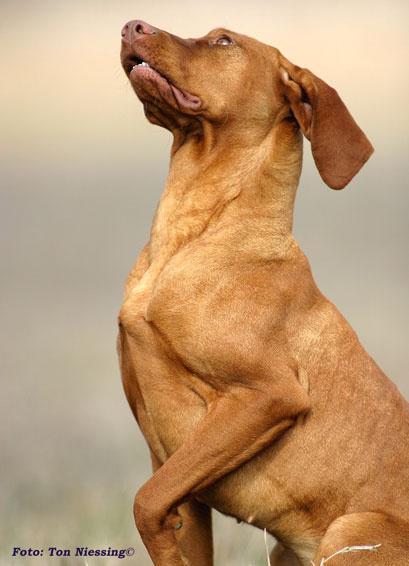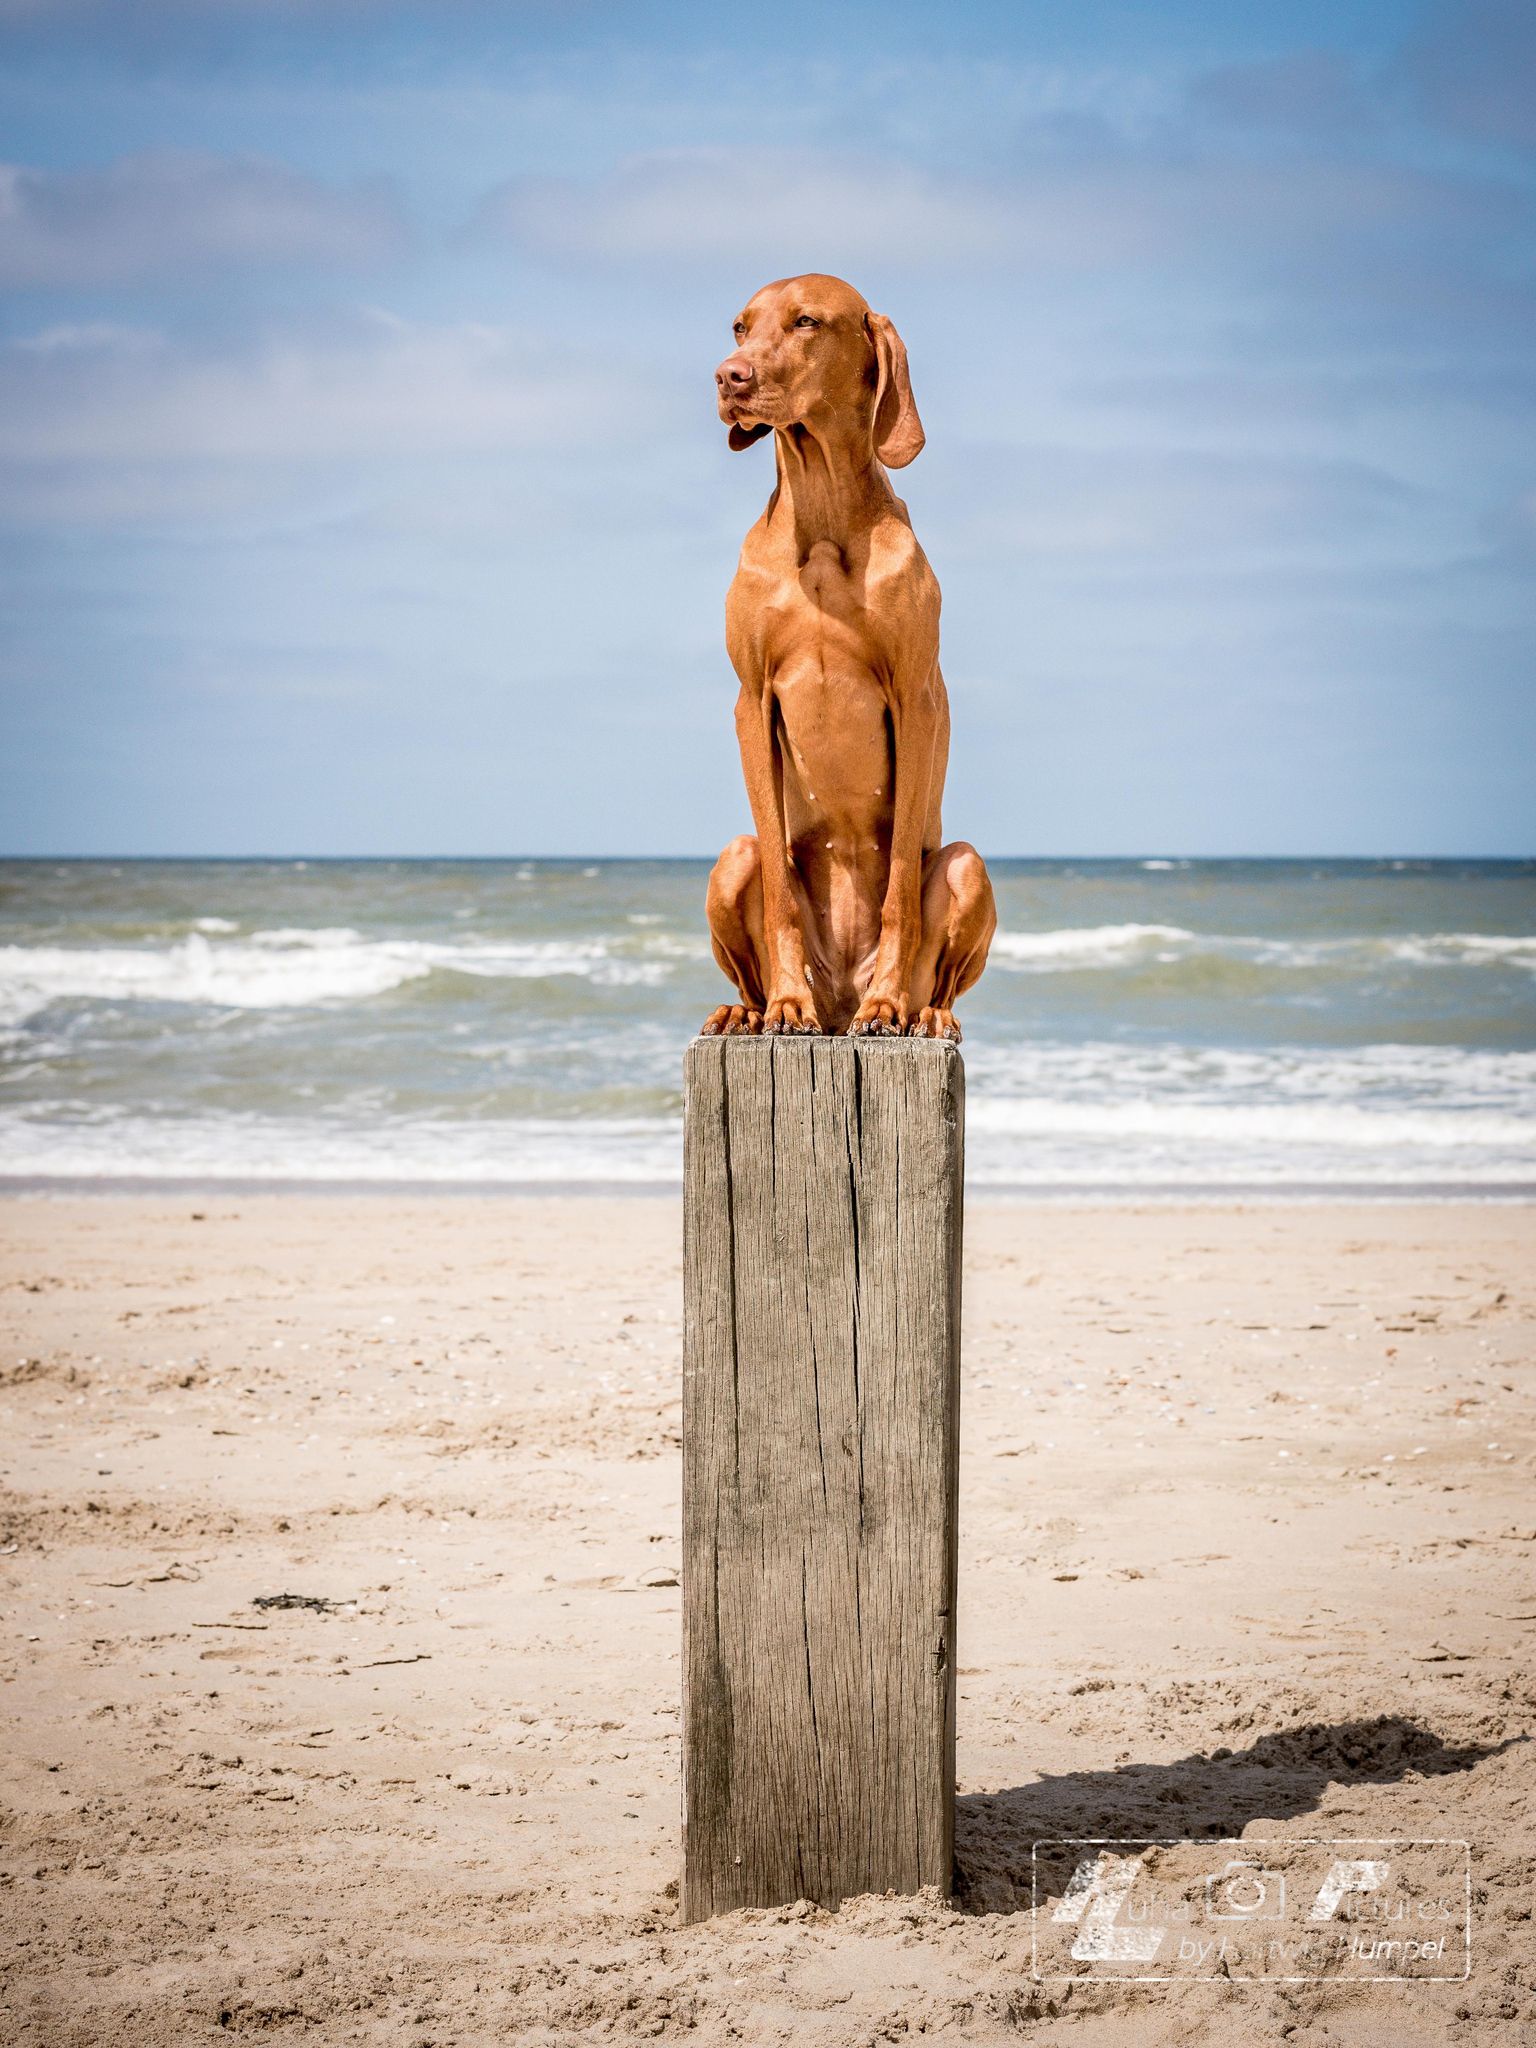The first image is the image on the left, the second image is the image on the right. For the images shown, is this caption "There are at least three dogs in total." true? Answer yes or no. No. The first image is the image on the left, the second image is the image on the right. Examine the images to the left and right. Is the description "Left and right images show an orange dog at the beach, and at least one image shows a dog that is not in the water." accurate? Answer yes or no. No. 